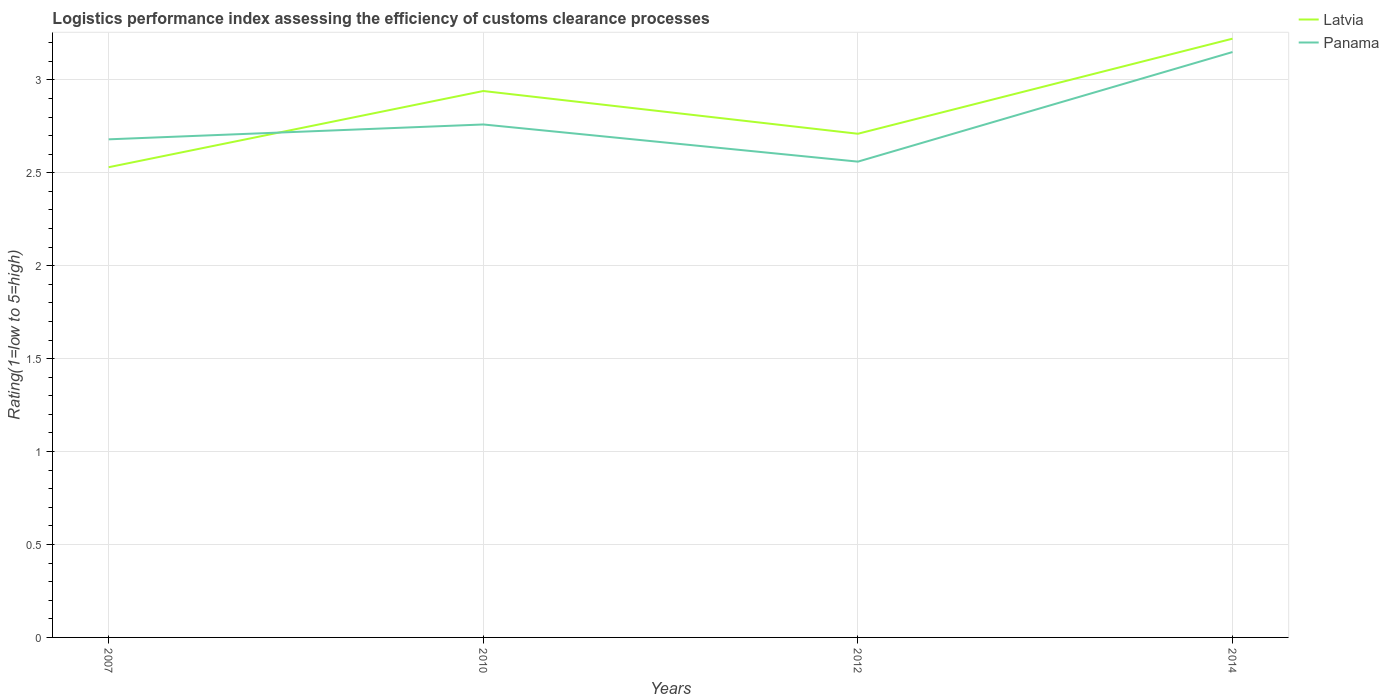How many different coloured lines are there?
Make the answer very short. 2. Is the number of lines equal to the number of legend labels?
Offer a very short reply. Yes. Across all years, what is the maximum Logistic performance index in Panama?
Give a very brief answer. 2.56. What is the total Logistic performance index in Panama in the graph?
Your answer should be compact. -0.47. What is the difference between the highest and the second highest Logistic performance index in Panama?
Your answer should be very brief. 0.59. What is the difference between the highest and the lowest Logistic performance index in Latvia?
Offer a very short reply. 2. How many years are there in the graph?
Provide a short and direct response. 4. Are the values on the major ticks of Y-axis written in scientific E-notation?
Provide a succinct answer. No. Does the graph contain grids?
Your response must be concise. Yes. Where does the legend appear in the graph?
Give a very brief answer. Top right. How are the legend labels stacked?
Offer a very short reply. Vertical. What is the title of the graph?
Offer a very short reply. Logistics performance index assessing the efficiency of customs clearance processes. What is the label or title of the X-axis?
Make the answer very short. Years. What is the label or title of the Y-axis?
Your answer should be compact. Rating(1=low to 5=high). What is the Rating(1=low to 5=high) of Latvia in 2007?
Your answer should be compact. 2.53. What is the Rating(1=low to 5=high) in Panama in 2007?
Your answer should be very brief. 2.68. What is the Rating(1=low to 5=high) in Latvia in 2010?
Offer a very short reply. 2.94. What is the Rating(1=low to 5=high) of Panama in 2010?
Offer a terse response. 2.76. What is the Rating(1=low to 5=high) of Latvia in 2012?
Give a very brief answer. 2.71. What is the Rating(1=low to 5=high) of Panama in 2012?
Give a very brief answer. 2.56. What is the Rating(1=low to 5=high) of Latvia in 2014?
Your response must be concise. 3.22. What is the Rating(1=low to 5=high) in Panama in 2014?
Give a very brief answer. 3.15. Across all years, what is the maximum Rating(1=low to 5=high) in Latvia?
Offer a very short reply. 3.22. Across all years, what is the maximum Rating(1=low to 5=high) of Panama?
Ensure brevity in your answer.  3.15. Across all years, what is the minimum Rating(1=low to 5=high) in Latvia?
Keep it short and to the point. 2.53. Across all years, what is the minimum Rating(1=low to 5=high) in Panama?
Provide a succinct answer. 2.56. What is the total Rating(1=low to 5=high) of Latvia in the graph?
Your response must be concise. 11.4. What is the total Rating(1=low to 5=high) of Panama in the graph?
Offer a very short reply. 11.15. What is the difference between the Rating(1=low to 5=high) in Latvia in 2007 and that in 2010?
Give a very brief answer. -0.41. What is the difference between the Rating(1=low to 5=high) in Panama in 2007 and that in 2010?
Your answer should be compact. -0.08. What is the difference between the Rating(1=low to 5=high) in Latvia in 2007 and that in 2012?
Your answer should be compact. -0.18. What is the difference between the Rating(1=low to 5=high) of Panama in 2007 and that in 2012?
Offer a terse response. 0.12. What is the difference between the Rating(1=low to 5=high) of Latvia in 2007 and that in 2014?
Provide a short and direct response. -0.69. What is the difference between the Rating(1=low to 5=high) of Panama in 2007 and that in 2014?
Offer a terse response. -0.47. What is the difference between the Rating(1=low to 5=high) in Latvia in 2010 and that in 2012?
Your response must be concise. 0.23. What is the difference between the Rating(1=low to 5=high) of Latvia in 2010 and that in 2014?
Provide a short and direct response. -0.28. What is the difference between the Rating(1=low to 5=high) in Panama in 2010 and that in 2014?
Provide a succinct answer. -0.39. What is the difference between the Rating(1=low to 5=high) in Latvia in 2012 and that in 2014?
Keep it short and to the point. -0.51. What is the difference between the Rating(1=low to 5=high) in Panama in 2012 and that in 2014?
Offer a terse response. -0.59. What is the difference between the Rating(1=low to 5=high) in Latvia in 2007 and the Rating(1=low to 5=high) in Panama in 2010?
Your answer should be very brief. -0.23. What is the difference between the Rating(1=low to 5=high) of Latvia in 2007 and the Rating(1=low to 5=high) of Panama in 2012?
Give a very brief answer. -0.03. What is the difference between the Rating(1=low to 5=high) in Latvia in 2007 and the Rating(1=low to 5=high) in Panama in 2014?
Your answer should be compact. -0.62. What is the difference between the Rating(1=low to 5=high) of Latvia in 2010 and the Rating(1=low to 5=high) of Panama in 2012?
Keep it short and to the point. 0.38. What is the difference between the Rating(1=low to 5=high) in Latvia in 2010 and the Rating(1=low to 5=high) in Panama in 2014?
Make the answer very short. -0.21. What is the difference between the Rating(1=low to 5=high) in Latvia in 2012 and the Rating(1=low to 5=high) in Panama in 2014?
Provide a short and direct response. -0.44. What is the average Rating(1=low to 5=high) in Latvia per year?
Offer a terse response. 2.85. What is the average Rating(1=low to 5=high) in Panama per year?
Keep it short and to the point. 2.79. In the year 2007, what is the difference between the Rating(1=low to 5=high) of Latvia and Rating(1=low to 5=high) of Panama?
Make the answer very short. -0.15. In the year 2010, what is the difference between the Rating(1=low to 5=high) in Latvia and Rating(1=low to 5=high) in Panama?
Offer a terse response. 0.18. In the year 2014, what is the difference between the Rating(1=low to 5=high) in Latvia and Rating(1=low to 5=high) in Panama?
Keep it short and to the point. 0.07. What is the ratio of the Rating(1=low to 5=high) of Latvia in 2007 to that in 2010?
Provide a short and direct response. 0.86. What is the ratio of the Rating(1=low to 5=high) in Latvia in 2007 to that in 2012?
Provide a short and direct response. 0.93. What is the ratio of the Rating(1=low to 5=high) of Panama in 2007 to that in 2012?
Offer a very short reply. 1.05. What is the ratio of the Rating(1=low to 5=high) in Latvia in 2007 to that in 2014?
Ensure brevity in your answer.  0.79. What is the ratio of the Rating(1=low to 5=high) in Panama in 2007 to that in 2014?
Your response must be concise. 0.85. What is the ratio of the Rating(1=low to 5=high) in Latvia in 2010 to that in 2012?
Provide a succinct answer. 1.08. What is the ratio of the Rating(1=low to 5=high) of Panama in 2010 to that in 2012?
Your answer should be compact. 1.08. What is the ratio of the Rating(1=low to 5=high) of Latvia in 2010 to that in 2014?
Keep it short and to the point. 0.91. What is the ratio of the Rating(1=low to 5=high) of Panama in 2010 to that in 2014?
Provide a short and direct response. 0.88. What is the ratio of the Rating(1=low to 5=high) of Latvia in 2012 to that in 2014?
Offer a very short reply. 0.84. What is the ratio of the Rating(1=low to 5=high) of Panama in 2012 to that in 2014?
Provide a short and direct response. 0.81. What is the difference between the highest and the second highest Rating(1=low to 5=high) in Latvia?
Give a very brief answer. 0.28. What is the difference between the highest and the second highest Rating(1=low to 5=high) in Panama?
Make the answer very short. 0.39. What is the difference between the highest and the lowest Rating(1=low to 5=high) of Latvia?
Make the answer very short. 0.69. What is the difference between the highest and the lowest Rating(1=low to 5=high) in Panama?
Your response must be concise. 0.59. 